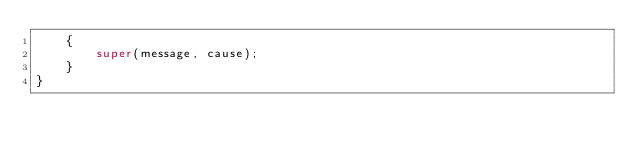<code> <loc_0><loc_0><loc_500><loc_500><_Java_>    {
        super(message, cause);
    }
}
</code> 